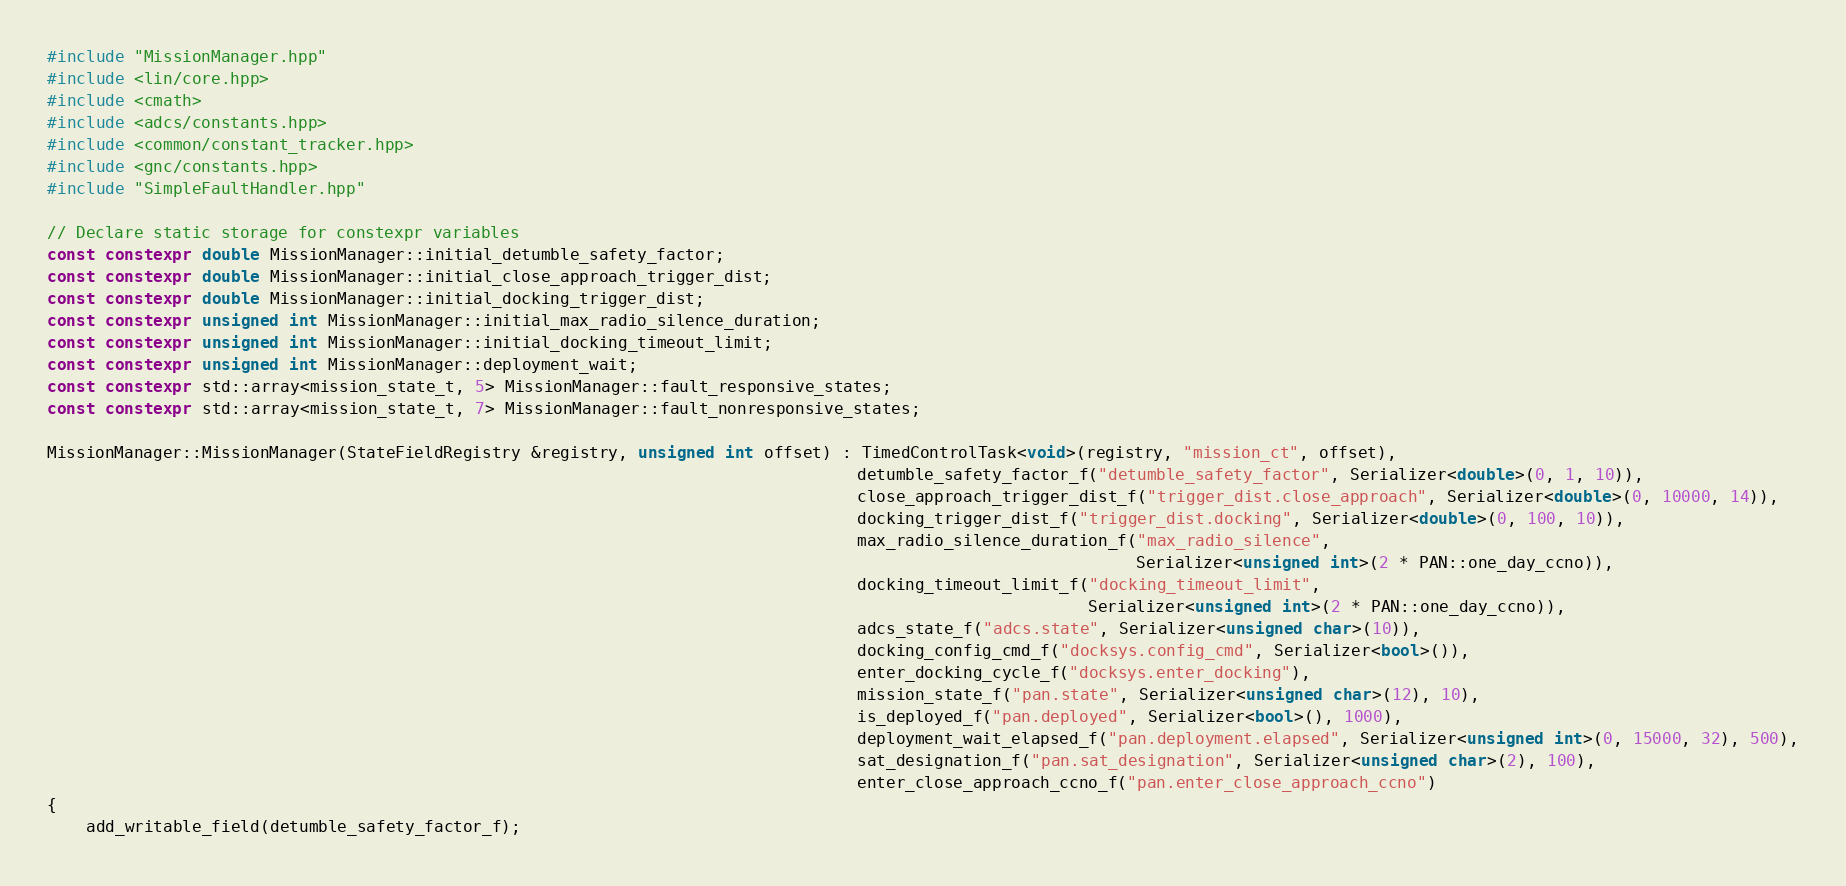<code> <loc_0><loc_0><loc_500><loc_500><_C++_>#include "MissionManager.hpp"
#include <lin/core.hpp>
#include <cmath>
#include <adcs/constants.hpp>
#include <common/constant_tracker.hpp>
#include <gnc/constants.hpp>
#include "SimpleFaultHandler.hpp"

// Declare static storage for constexpr variables
const constexpr double MissionManager::initial_detumble_safety_factor;
const constexpr double MissionManager::initial_close_approach_trigger_dist;
const constexpr double MissionManager::initial_docking_trigger_dist;
const constexpr unsigned int MissionManager::initial_max_radio_silence_duration;
const constexpr unsigned int MissionManager::initial_docking_timeout_limit;
const constexpr unsigned int MissionManager::deployment_wait;
const constexpr std::array<mission_state_t, 5> MissionManager::fault_responsive_states;
const constexpr std::array<mission_state_t, 7> MissionManager::fault_nonresponsive_states;

MissionManager::MissionManager(StateFieldRegistry &registry, unsigned int offset) : TimedControlTask<void>(registry, "mission_ct", offset),
                                                                                    detumble_safety_factor_f("detumble_safety_factor", Serializer<double>(0, 1, 10)),
                                                                                    close_approach_trigger_dist_f("trigger_dist.close_approach", Serializer<double>(0, 10000, 14)),
                                                                                    docking_trigger_dist_f("trigger_dist.docking", Serializer<double>(0, 100, 10)),
                                                                                    max_radio_silence_duration_f("max_radio_silence",
                                                                                                                 Serializer<unsigned int>(2 * PAN::one_day_ccno)),
                                                                                    docking_timeout_limit_f("docking_timeout_limit",
                                                                                                            Serializer<unsigned int>(2 * PAN::one_day_ccno)),
                                                                                    adcs_state_f("adcs.state", Serializer<unsigned char>(10)),
                                                                                    docking_config_cmd_f("docksys.config_cmd", Serializer<bool>()),
                                                                                    enter_docking_cycle_f("docksys.enter_docking"),
                                                                                    mission_state_f("pan.state", Serializer<unsigned char>(12), 10),
                                                                                    is_deployed_f("pan.deployed", Serializer<bool>(), 1000),
                                                                                    deployment_wait_elapsed_f("pan.deployment.elapsed", Serializer<unsigned int>(0, 15000, 32), 500),
                                                                                    sat_designation_f("pan.sat_designation", Serializer<unsigned char>(2), 100),
                                                                                    enter_close_approach_ccno_f("pan.enter_close_approach_ccno")
{
    add_writable_field(detumble_safety_factor_f);</code> 